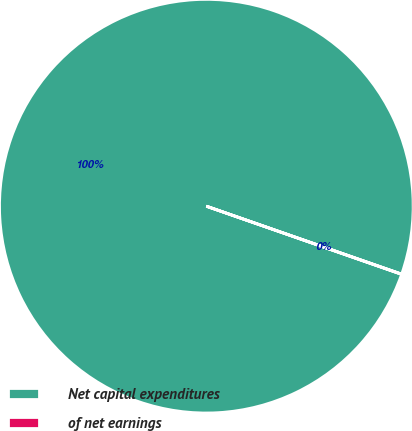Convert chart to OTSL. <chart><loc_0><loc_0><loc_500><loc_500><pie_chart><fcel>Net capital expenditures<fcel>of net earnings<nl><fcel>99.98%<fcel>0.02%<nl></chart> 